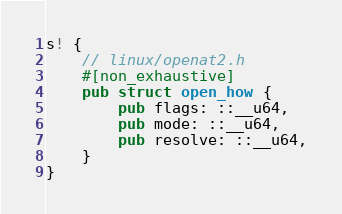Convert code to text. <code><loc_0><loc_0><loc_500><loc_500><_Rust_>s! {
    // linux/openat2.h
    #[non_exhaustive]
    pub struct open_how {
        pub flags: ::__u64,
        pub mode: ::__u64,
        pub resolve: ::__u64,
    }
}
</code> 